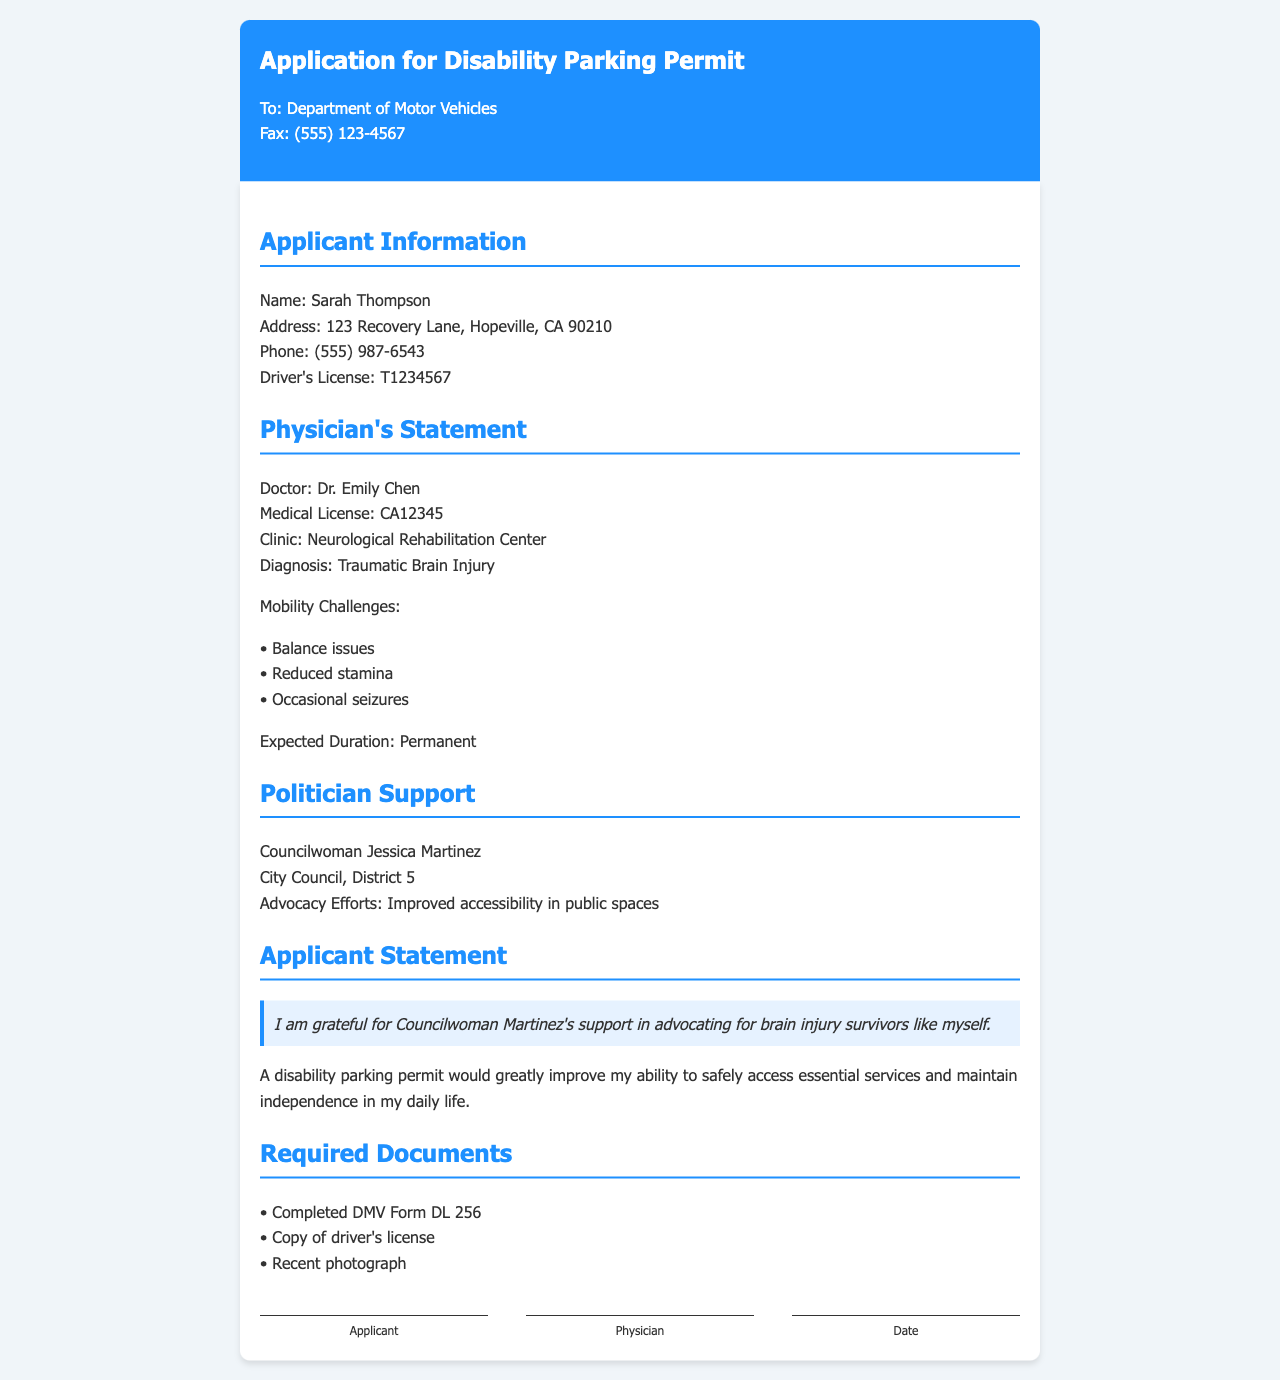What is the applicant's name? The applicant's name is mentioned in the section for applicant information.
Answer: Sarah Thompson Who is the physician? The physician's name appears in the physician's statement section.
Answer: Dr. Emily Chen What is the diagnosis listed? The diagnosis is specified under the physician's statement section.
Answer: Traumatic Brain Injury What mobility challenge involves energy levels? This challenge is noted in the physician's statement among the listed mobility issues.
Answer: Reduced stamina How long is the expected duration of mobility challenges? This information is provided in the physician's statement section regarding the duration.
Answer: Permanent Who supports the applicant's permit application? The supporter is mentioned in the politician support section of the document.
Answer: Councilwoman Jessica Martinez What is the address of the applicant? The address is included in the applicant information section.
Answer: 123 Recovery Lane, Hopeville, CA 90210 What is one required document listed in the fax? This is outlined in the required documents section of the fax.
Answer: Completed DMV Form DL 256 In which city council district does the supporter serve? This information is found in the politician's support section of the document.
Answer: District 5 What purpose does the disability parking permit serve according to the applicant? This is expressed in the applicant's statement portion of the document.
Answer: Access essential services and maintain independence 